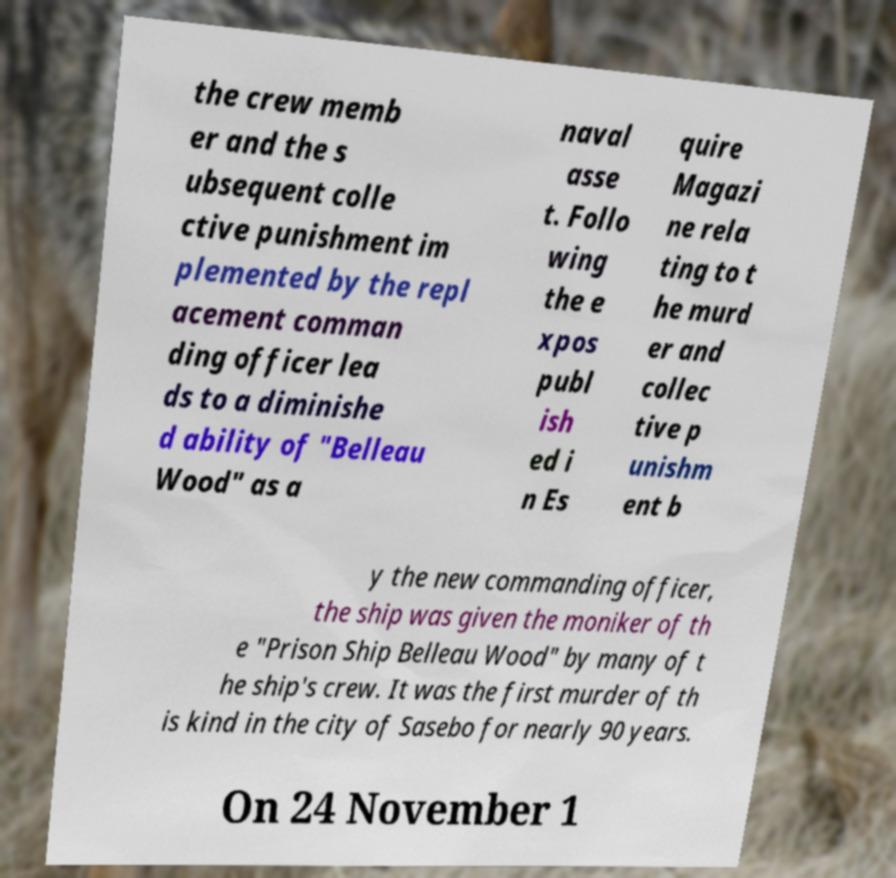Can you read and provide the text displayed in the image?This photo seems to have some interesting text. Can you extract and type it out for me? the crew memb er and the s ubsequent colle ctive punishment im plemented by the repl acement comman ding officer lea ds to a diminishe d ability of "Belleau Wood" as a naval asse t. Follo wing the e xpos publ ish ed i n Es quire Magazi ne rela ting to t he murd er and collec tive p unishm ent b y the new commanding officer, the ship was given the moniker of th e "Prison Ship Belleau Wood" by many of t he ship's crew. It was the first murder of th is kind in the city of Sasebo for nearly 90 years. On 24 November 1 